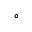<formula> <loc_0><loc_0><loc_500><loc_500>^ { \circ }</formula> 